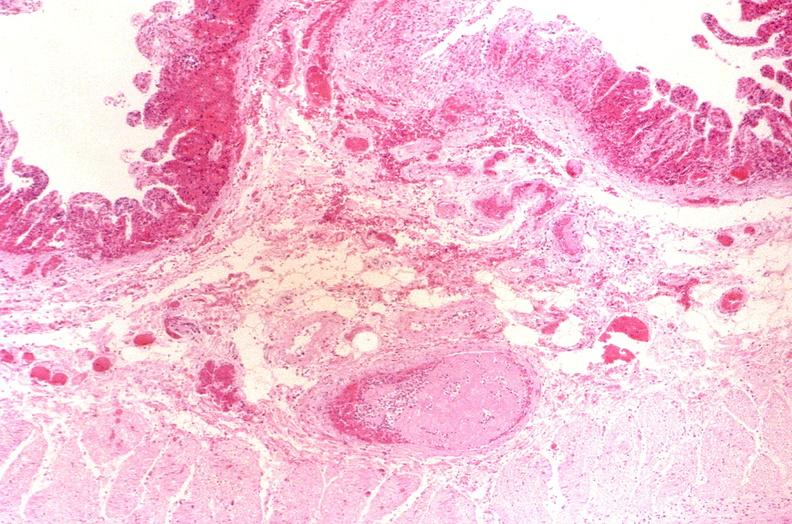what is present?
Answer the question using a single word or phrase. Gastrointestinal 